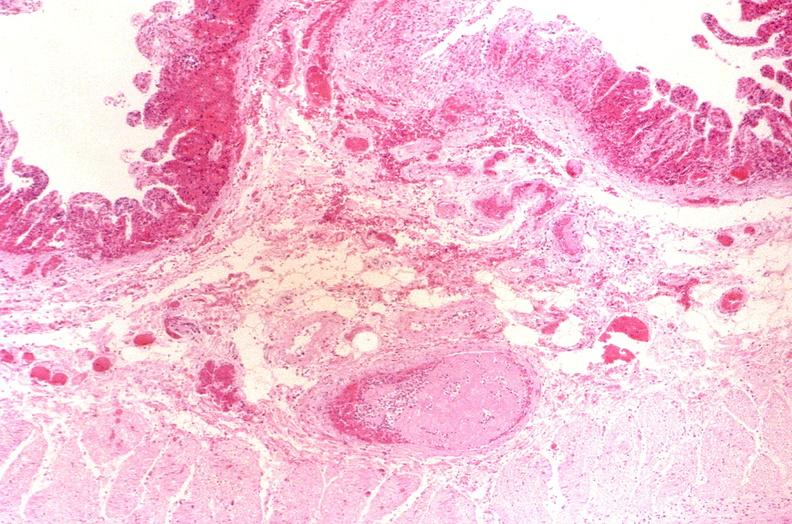what is present?
Answer the question using a single word or phrase. Gastrointestinal 